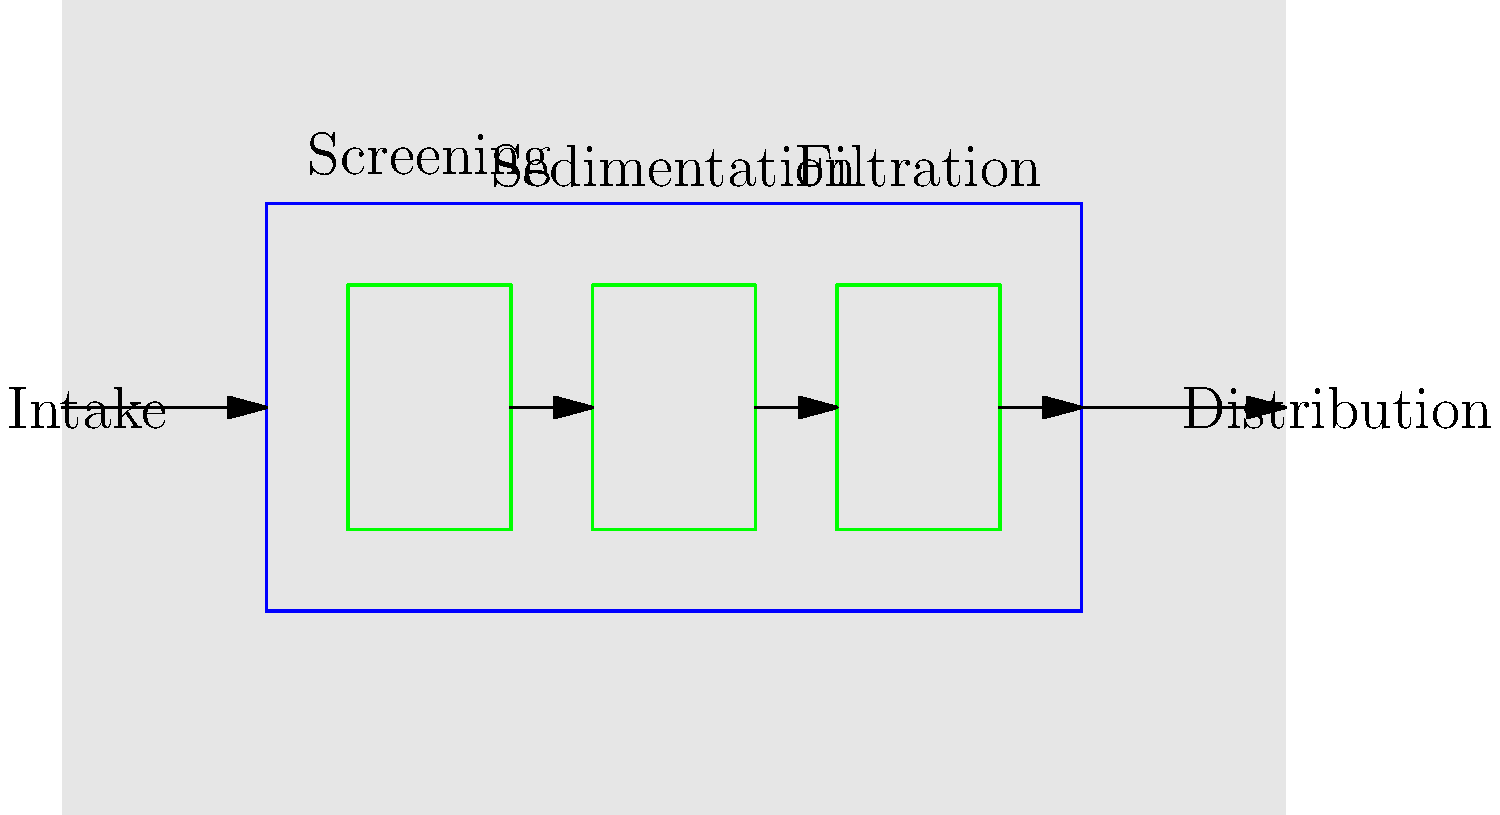As a parent involved in the school's PTA, you're organizing an educational field trip to a local water treatment plant. To prepare, you need to understand the basic layout of a water treatment plant. Based on the diagram, what is the correct order of the main treatment processes shown? To answer this question, let's analyze the diagram step-by-step:

1. The water flow is represented by arrows moving from left to right.
2. The first labeled component on the left is "Intake", where raw water enters the treatment plant.
3. Following the flow, we see three main treatment processes represented by green boxes:
   a. The first green box is labeled "Screening"
   b. The second green box is labeled "Sedimentation"
   c. The third green box is labeled "Filtration"
4. After these processes, we see the final arrow leading to "Distribution", where treated water exits the plant.

Therefore, the correct order of the main treatment processes shown in the diagram is:

Screening → Sedimentation → Filtration

This sequence represents a typical basic water treatment process:
- Screening removes large debris
- Sedimentation allows heavier particles to settle out
- Filtration removes smaller particles that remain suspended in the water

Understanding this process can help parents appreciate the importance of clean water and the technology involved in providing it to their children's school and community.
Answer: Screening, Sedimentation, Filtration 